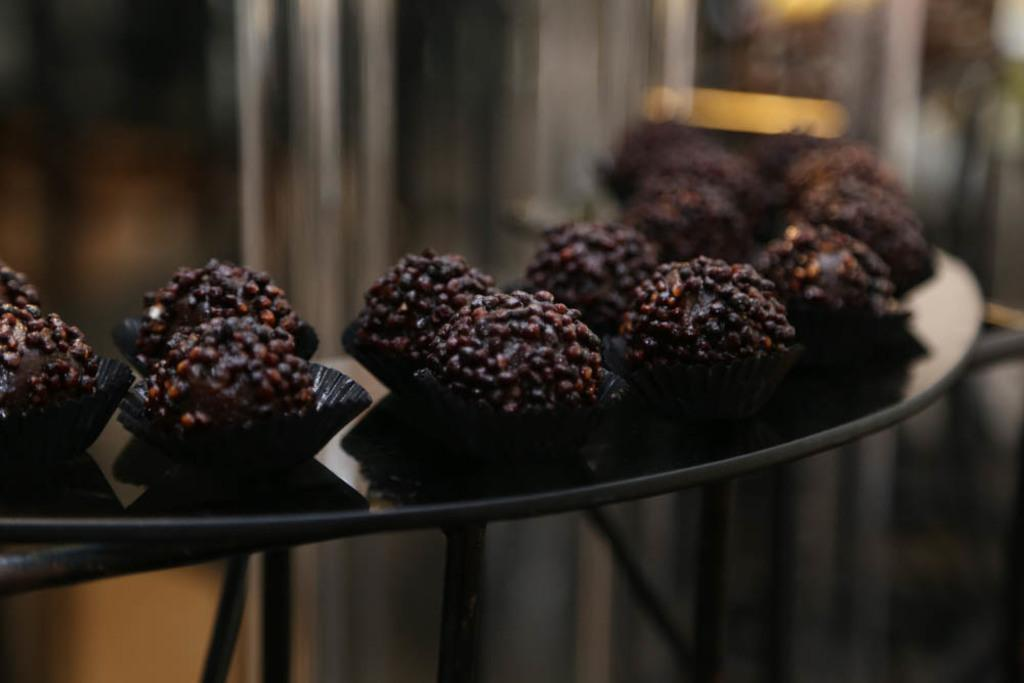What is depicted in the image? There are food items present in the image. Where are the food items located? The food items are on a table. What type of business is being conducted in the image? There is no indication of any business being conducted in the image; it only shows food items on a table. 